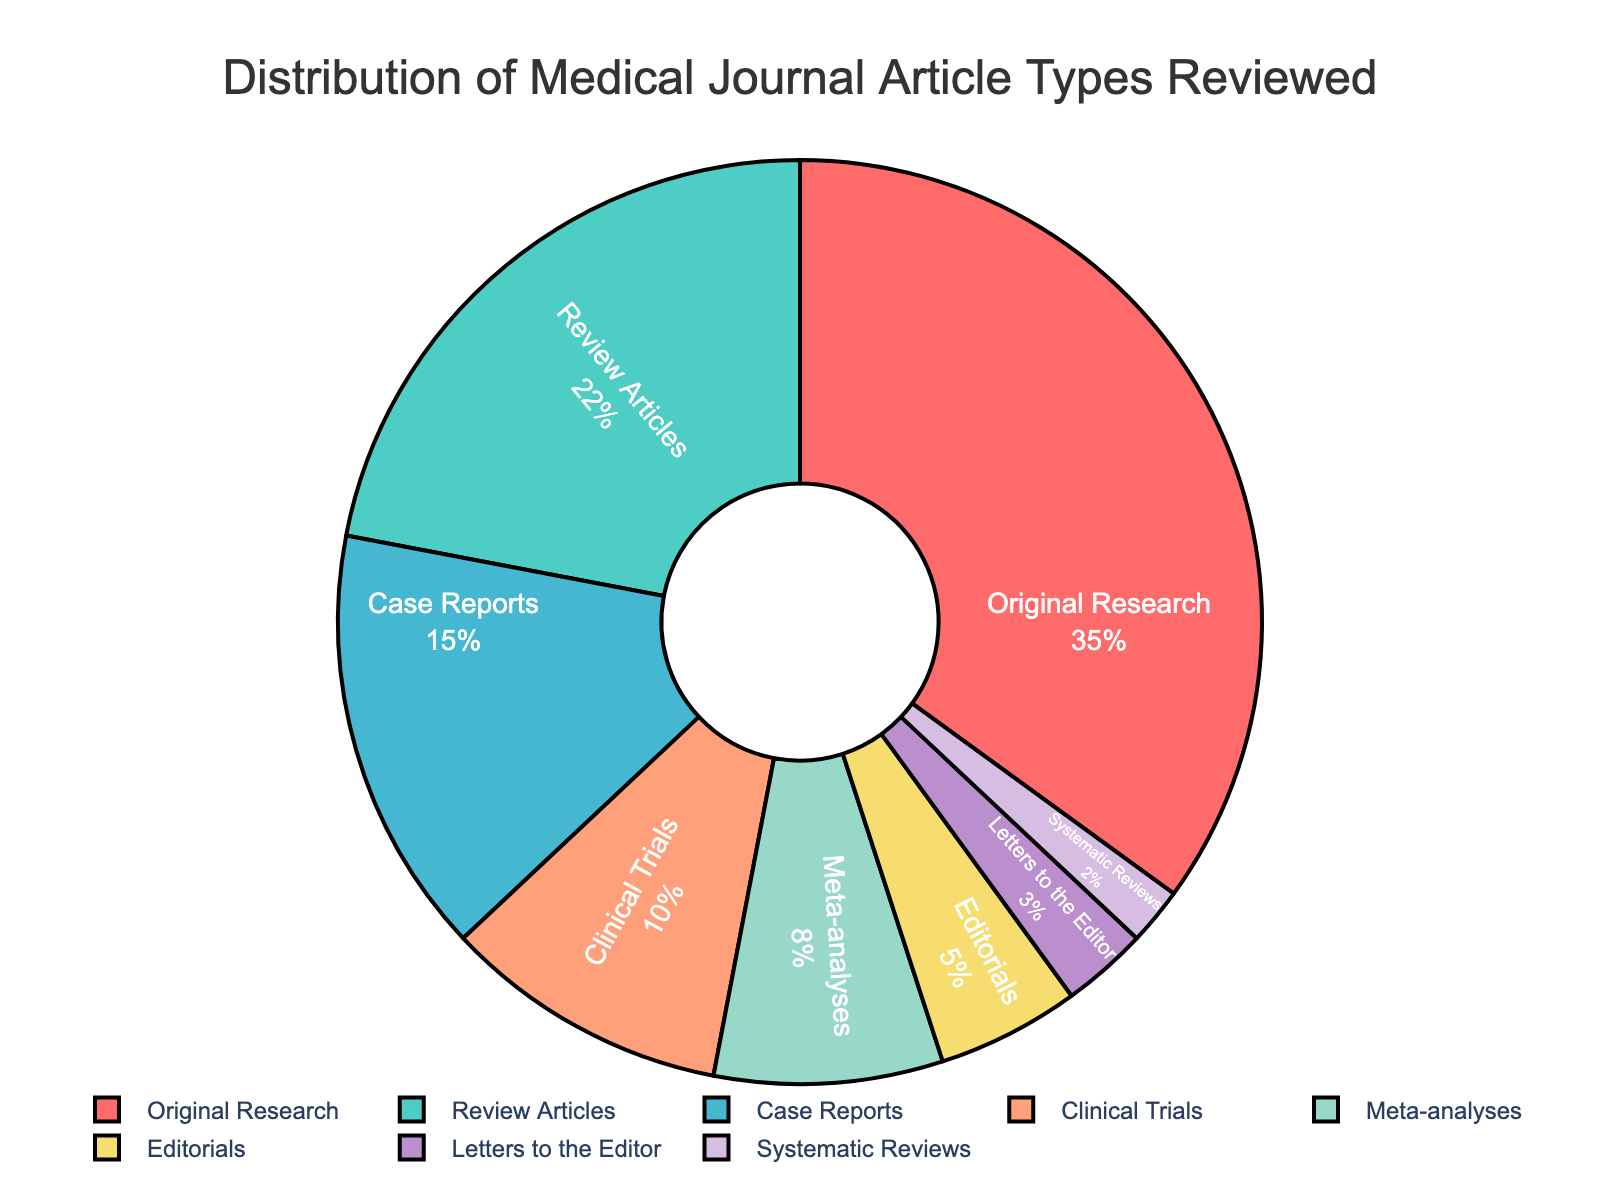What type of medical article is reviewed most frequently? According to the pie chart, the largest slice corresponds to "Original Research," which indicates it has the highest percentage.
Answer: Original Research What is the percentage of Review Articles in the distribution? The pie chart shows each segment's percentage, and the segment for Review Articles shows 22%.
Answer: 22% Which type of article has a lower percentage, Clinical Trials or Editorials? By comparing their respective slices on the pie chart, Editorials have 5%, whereas Clinical Trials have 10%. Therefore, Editorials have a lower percentage.
Answer: Editorials Are there more reviews (combining Review Articles and Systematic Reviews) or original works (Original Research)? Review Articles are 22%, and Systematic Reviews are 2%, giving a total of 24% for reviews. Original Research alone is 35%. Therefore, there are more original works.
Answer: Original Research What two types of articles have an equal combined percentage as Meta-analyses? Meta-analyses have a percentage of 8%. Combining Editorials (5%) and Letters to the Editor (3%) also sums up to 8%.
Answer: Editorials and Letters to the Editor What is the combined percentage of Case Reports and Clinical Trials? By adding the percentages of Case Reports (15%) and Clinical Trials (10%), the combined percentage is 25%.
Answer: 25% Which type of medical article reviewed has the smallest percentage, and what color is its segment in the pie chart? The slice representing Systematic Reviews is the smallest, with a 2% share. This segment is visually distinct with a light purple color.
Answer: Systematic Reviews, light purple Is the percentage of Letters to the Editor greater than that of Systematic Reviews? Looking at the pie chart, Letters to the Editor have a percentage of 3%, while Systematic Reviews have a percentage of 2%. Therefore, Letters to the Editor have a greater percentage.
Answer: Yes What is the difference in percentage between Meta-analyses and Review Articles? Meta-analyses have an 8% share, whereas Review Articles have 22%. The difference is 22% - 8% = 14%.
Answer: 14% What is the sum of the percentages for Editorials, Letters to the Editor, and Systematic Reviews? Adding the percentages for Editorials (5%), Letters to the Editor (3%), and Systematic Reviews (2%) gives 5% + 3% + 2% = 10%.
Answer: 10% 